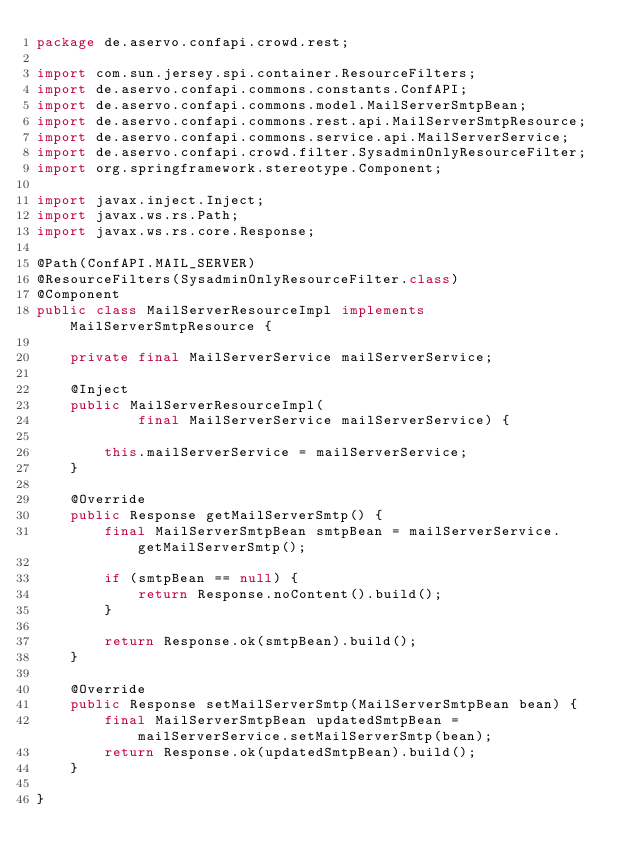Convert code to text. <code><loc_0><loc_0><loc_500><loc_500><_Java_>package de.aservo.confapi.crowd.rest;

import com.sun.jersey.spi.container.ResourceFilters;
import de.aservo.confapi.commons.constants.ConfAPI;
import de.aservo.confapi.commons.model.MailServerSmtpBean;
import de.aservo.confapi.commons.rest.api.MailServerSmtpResource;
import de.aservo.confapi.commons.service.api.MailServerService;
import de.aservo.confapi.crowd.filter.SysadminOnlyResourceFilter;
import org.springframework.stereotype.Component;

import javax.inject.Inject;
import javax.ws.rs.Path;
import javax.ws.rs.core.Response;

@Path(ConfAPI.MAIL_SERVER)
@ResourceFilters(SysadminOnlyResourceFilter.class)
@Component
public class MailServerResourceImpl implements MailServerSmtpResource {

    private final MailServerService mailServerService;

    @Inject
    public MailServerResourceImpl(
            final MailServerService mailServerService) {

        this.mailServerService = mailServerService;
    }

    @Override
    public Response getMailServerSmtp() {
        final MailServerSmtpBean smtpBean = mailServerService.getMailServerSmtp();

        if (smtpBean == null) {
            return Response.noContent().build();
        }

        return Response.ok(smtpBean).build();
    }

    @Override
    public Response setMailServerSmtp(MailServerSmtpBean bean) {
        final MailServerSmtpBean updatedSmtpBean = mailServerService.setMailServerSmtp(bean);
        return Response.ok(updatedSmtpBean).build();
    }

}
</code> 